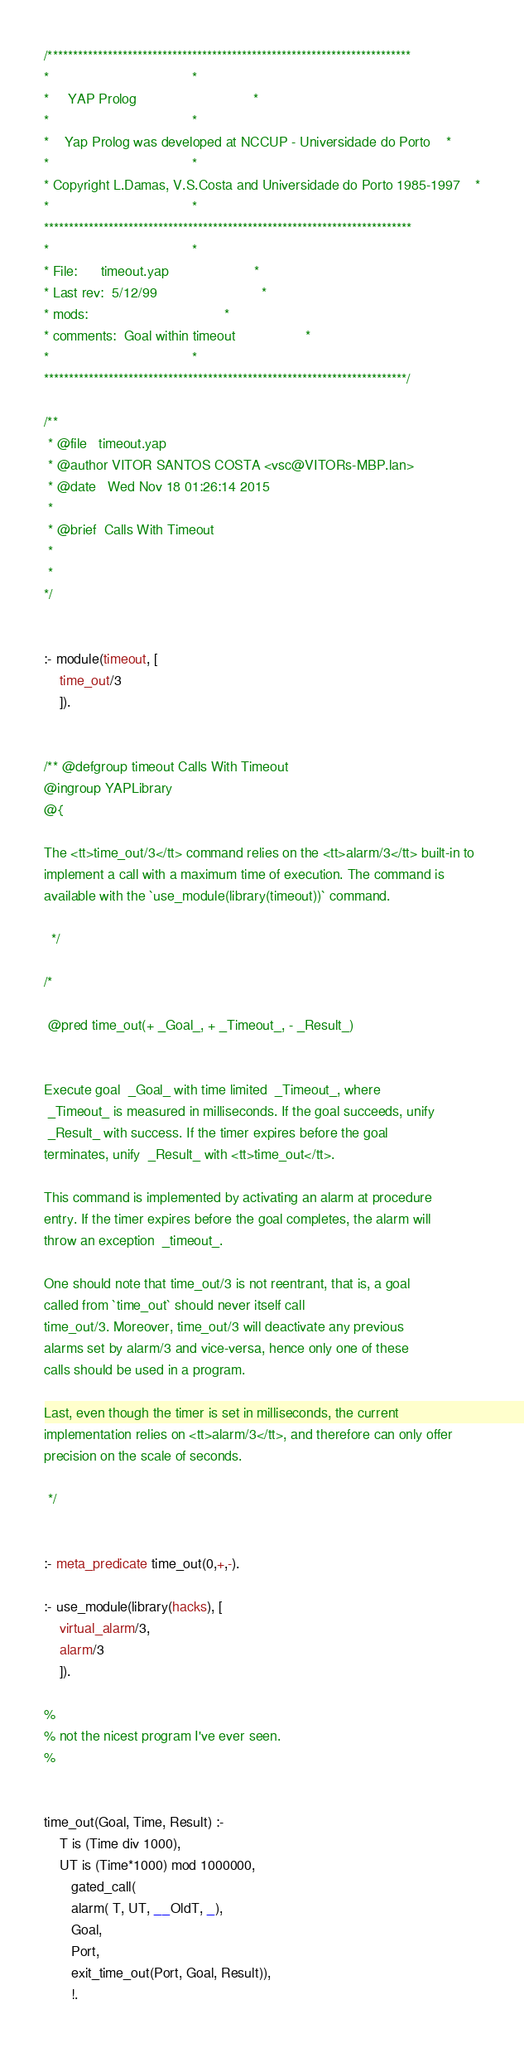<code> <loc_0><loc_0><loc_500><loc_500><_Prolog_>/*************************************************************************
*									 *
*	 YAP Prolog 							 *
*									 *
*	Yap Prolog was developed at NCCUP - Universidade do Porto	 *
*									 *
* Copyright L.Damas, V.S.Costa and Universidade do Porto 1985-1997	 *
*									 *
**************************************************************************
*									 *
* File:		timeout.yap						 *
* Last rev:	5/12/99							 *
* mods:									 *
* comments:	Goal within timeout					 *
*									 *
*************************************************************************/

/**
 * @file   timeout.yap
 * @author VITOR SANTOS COSTA <vsc@VITORs-MBP.lan>
 * @date   Wed Nov 18 01:26:14 2015
 * 
 * @brief  Calls With Timeout
 * 
 * 
*/


:- module(timeout, [
	time_out/3
    ]).


/** @defgroup timeout Calls With Timeout
@ingroup YAPLibrary
@{

The <tt>time_out/3</tt> command relies on the <tt>alarm/3</tt> built-in to
implement a call with a maximum time of execution. The command is
available with the `use_module(library(timeout))` command.

  */

/*
  
 @pred time_out(+ _Goal_, + _Timeout_, - _Result_) 


Execute goal  _Goal_ with time limited  _Timeout_, where
 _Timeout_ is measured in milliseconds. If the goal succeeds, unify
 _Result_ with success. If the timer expires before the goal
terminates, unify  _Result_ with <tt>time_out</tt>.

This command is implemented by activating an alarm at procedure
entry. If the timer expires before the goal completes, the alarm will
throw an exception  _timeout_.

One should note that time_out/3 is not reentrant, that is, a goal
called from `time_out` should never itself call
time_out/3. Moreover, time_out/3 will deactivate any previous
alarms set by alarm/3 and vice-versa, hence only one of these
calls should be used in a program.

Last, even though the timer is set in milliseconds, the current
implementation relies on <tt>alarm/3</tt>, and therefore can only offer
precision on the scale of seconds.

 */


:- meta_predicate time_out(0,+,-).

:- use_module(library(hacks), [
	virtual_alarm/3,
	alarm/3
    ]).

%
% not the nicest program I've ever seen.
%


time_out(Goal, Time, Result) :-
	T is (Time div 1000),
	UT is (Time*1000) mod 1000000,
       gated_call(
	   alarm( T, UT, __OldT, _),
	   Goal,
	   Port,
	   exit_time_out(Port, Goal, Result)),
       !.

</code> 